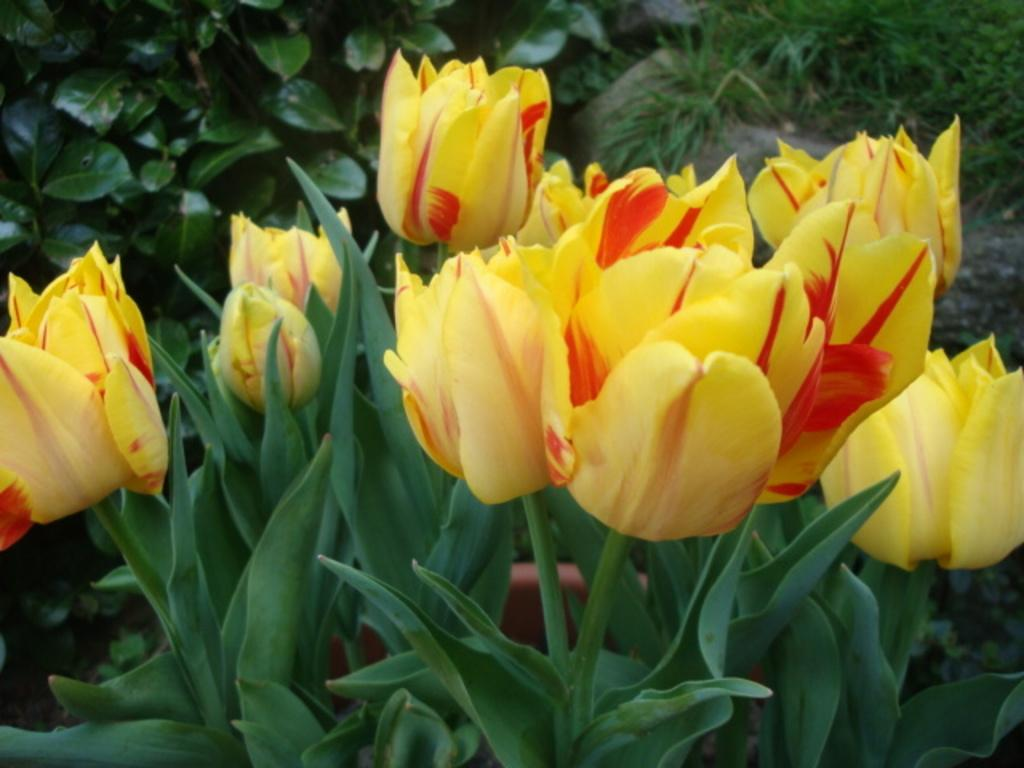What type of plants can be seen in the image? There are flower plants in the image. What can be seen in the background of the image? There are plants and stones in the background of the image. What does the mouth of the flower plant look like in the image? There is no mouth present on the flower plants in the image, as they are not living beings with mouths. 